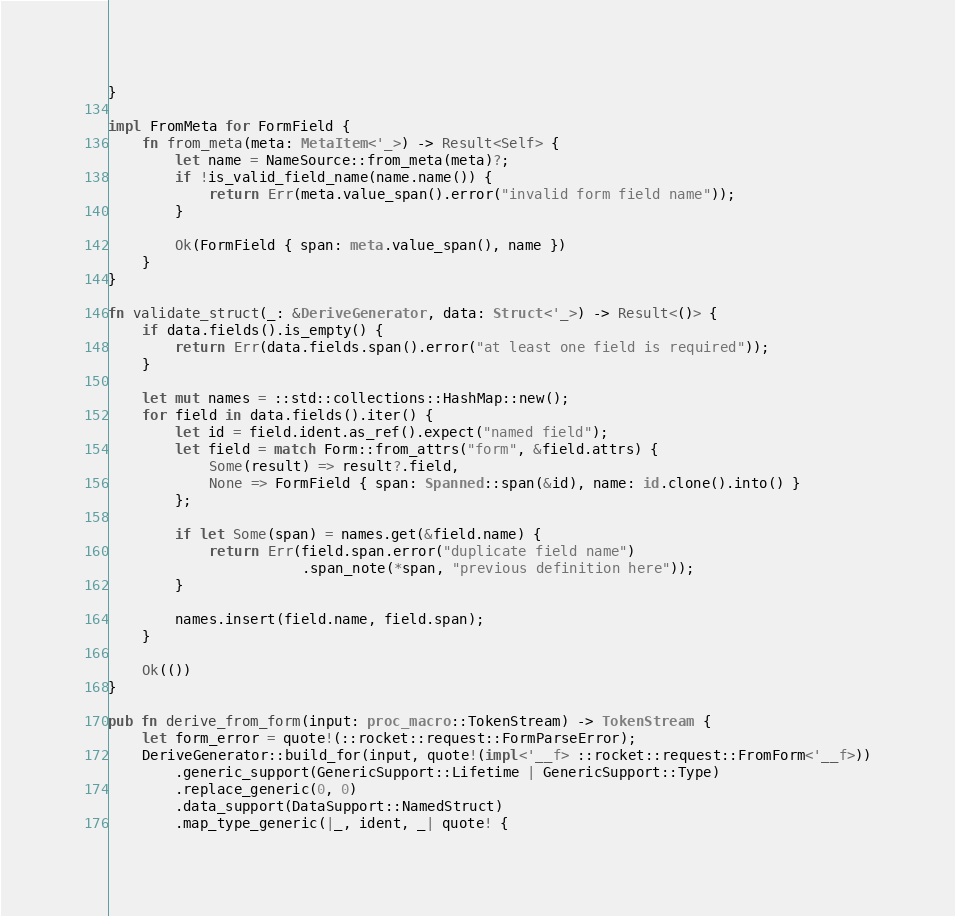Convert code to text. <code><loc_0><loc_0><loc_500><loc_500><_Rust_>}

impl FromMeta for FormField {
    fn from_meta(meta: MetaItem<'_>) -> Result<Self> {
        let name = NameSource::from_meta(meta)?;
        if !is_valid_field_name(name.name()) {
            return Err(meta.value_span().error("invalid form field name"));
        }

        Ok(FormField { span: meta.value_span(), name })
    }
}

fn validate_struct(_: &DeriveGenerator, data: Struct<'_>) -> Result<()> {
    if data.fields().is_empty() {
        return Err(data.fields.span().error("at least one field is required"));
    }

    let mut names = ::std::collections::HashMap::new();
    for field in data.fields().iter() {
        let id = field.ident.as_ref().expect("named field");
        let field = match Form::from_attrs("form", &field.attrs) {
            Some(result) => result?.field,
            None => FormField { span: Spanned::span(&id), name: id.clone().into() }
        };

        if let Some(span) = names.get(&field.name) {
            return Err(field.span.error("duplicate field name")
                       .span_note(*span, "previous definition here"));
        }

        names.insert(field.name, field.span);
    }

    Ok(())
}

pub fn derive_from_form(input: proc_macro::TokenStream) -> TokenStream {
    let form_error = quote!(::rocket::request::FormParseError);
    DeriveGenerator::build_for(input, quote!(impl<'__f> ::rocket::request::FromForm<'__f>))
        .generic_support(GenericSupport::Lifetime | GenericSupport::Type)
        .replace_generic(0, 0)
        .data_support(DataSupport::NamedStruct)
        .map_type_generic(|_, ident, _| quote! {</code> 